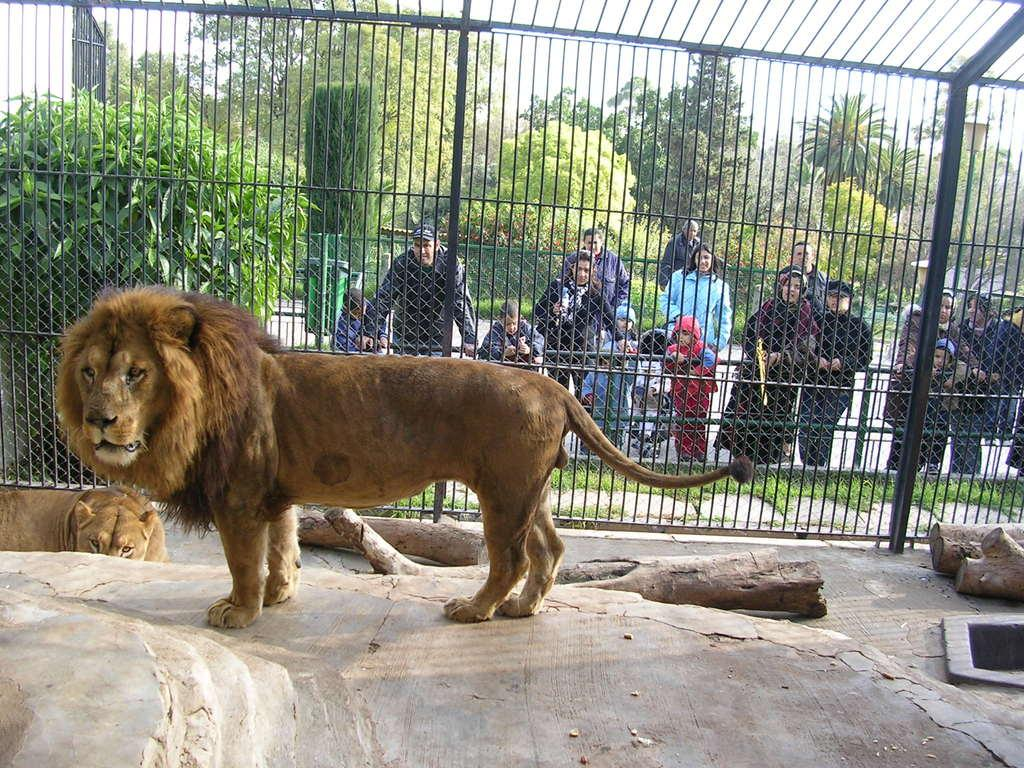How many lions are in the image? There are two lions in the image. What objects are made of wood in the image? There are wooden logs in the image. What type of barrier is present in the image? There is a fence in the image. What type of containers are in the image? There are bins in the image. What type of vegetation is in the image? There are trees in the image. What is the position of the group of people in the image? The group of people is standing on the ground in the image. What is visible in the background of the image? The sky is visible in the background of the image. What type of bean is being grown in the image? There is no bean or bean-growing activity present in the image. What grade is the lion in the image? The image does not indicate any grades or levels of achievement for the lions, as they are animals and not students. 